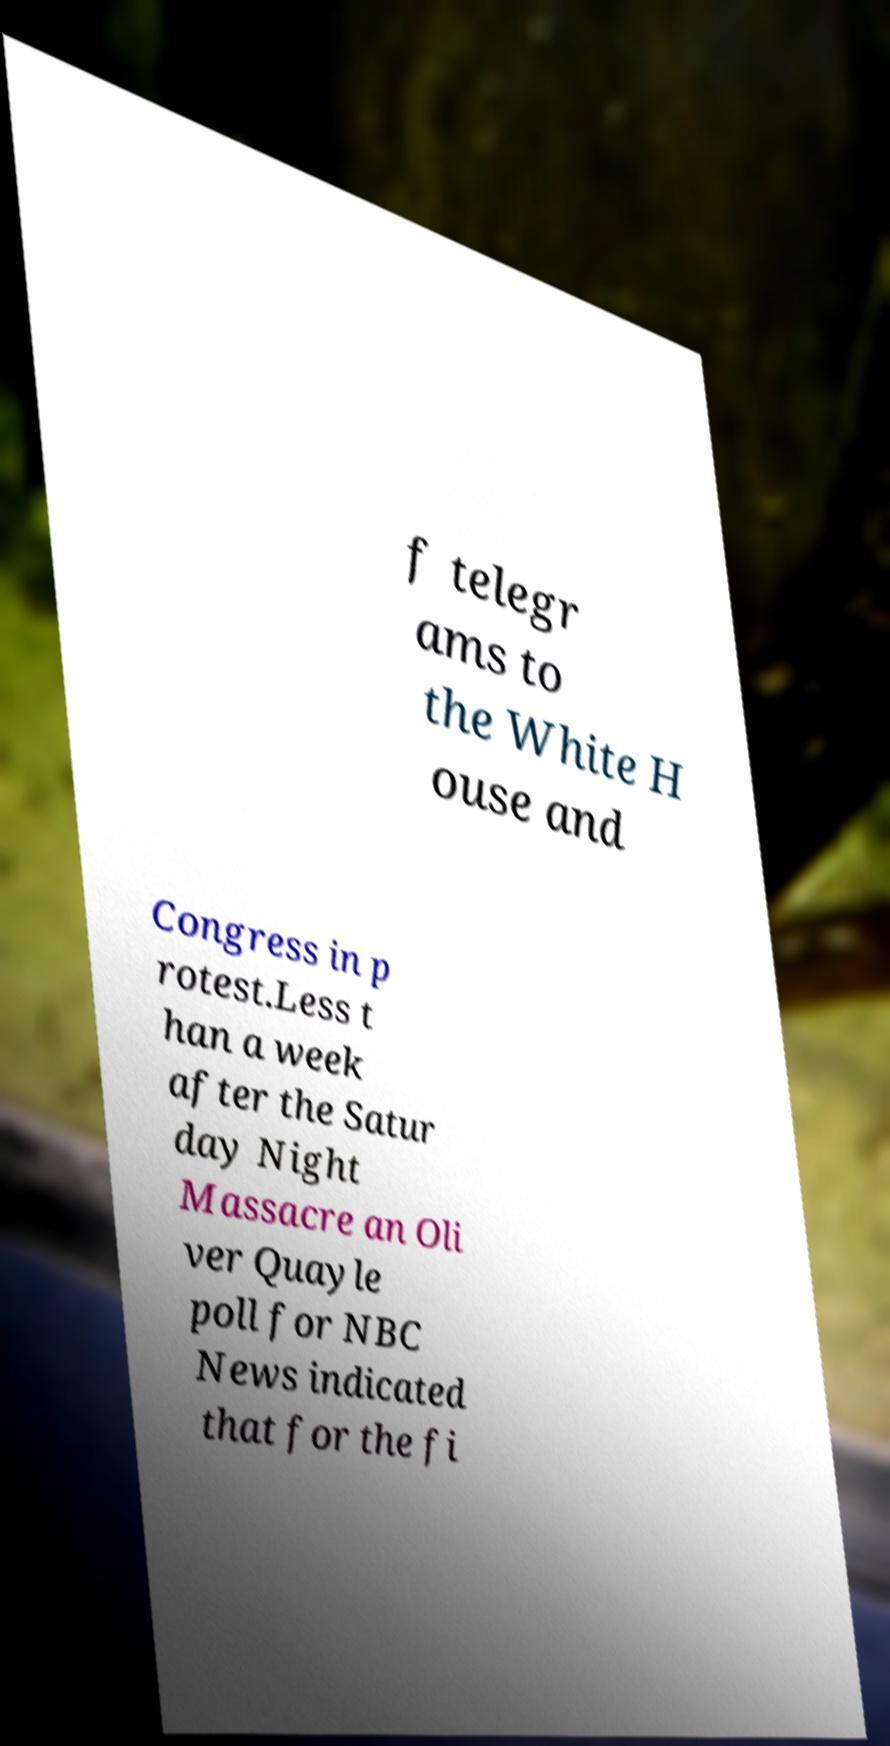What messages or text are displayed in this image? I need them in a readable, typed format. f telegr ams to the White H ouse and Congress in p rotest.Less t han a week after the Satur day Night Massacre an Oli ver Quayle poll for NBC News indicated that for the fi 